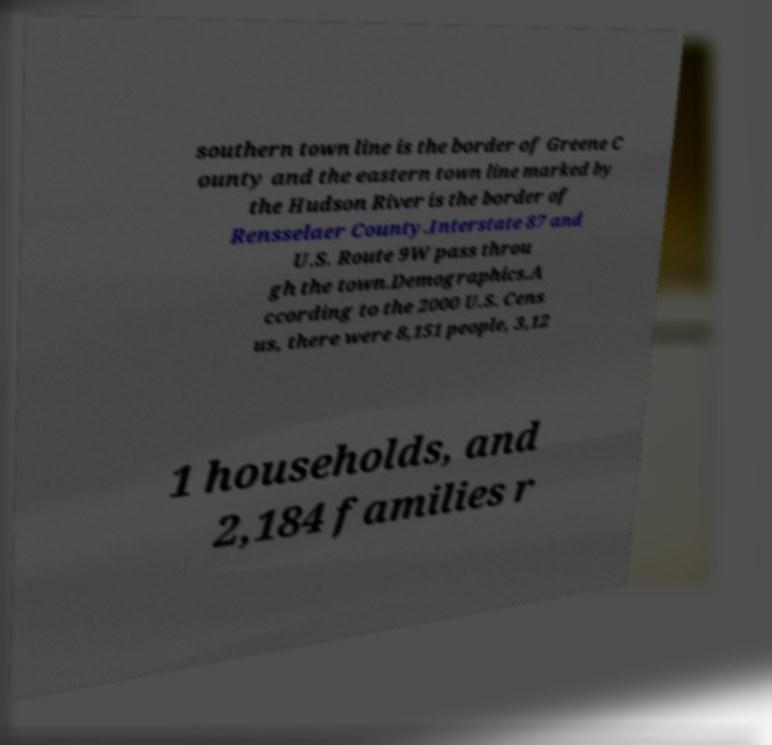There's text embedded in this image that I need extracted. Can you transcribe it verbatim? southern town line is the border of Greene C ounty and the eastern town line marked by the Hudson River is the border of Rensselaer County.Interstate 87 and U.S. Route 9W pass throu gh the town.Demographics.A ccording to the 2000 U.S. Cens us, there were 8,151 people, 3,12 1 households, and 2,184 families r 